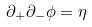<formula> <loc_0><loc_0><loc_500><loc_500>\partial _ { + } \partial _ { - } \phi = \eta</formula> 